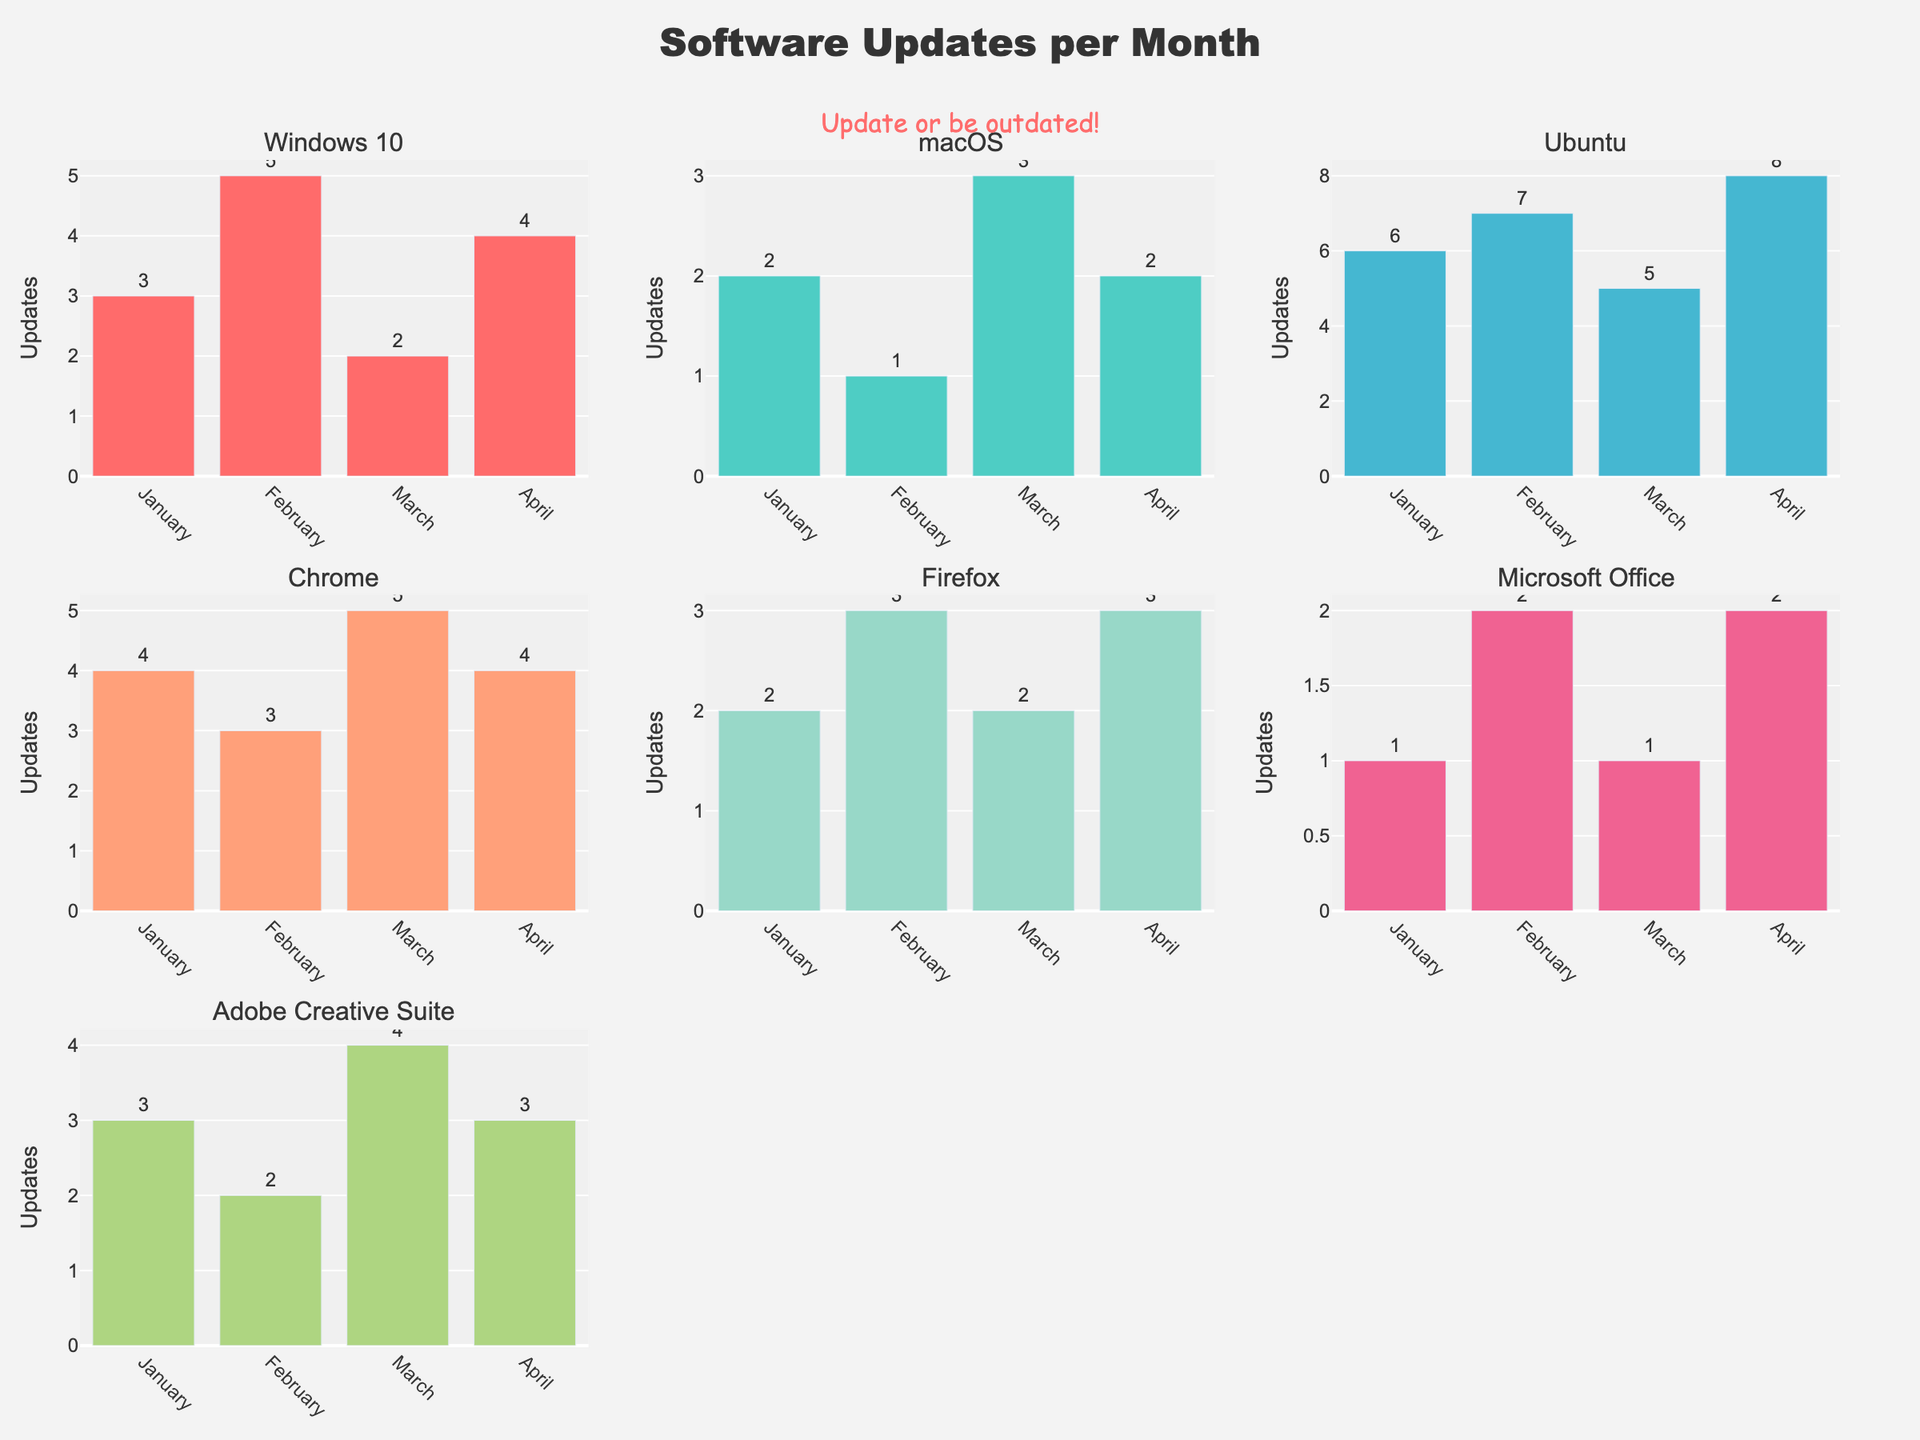Which operating system had the highest number of updates in February? Looking at the February updates across all subplots, Ubuntu recorded the highest with 7 updates.
Answer: Ubuntu How many updates did macOS receive in total over the four months? Summing the updates for macOS across January (2), February (1), March (3), and April (2): 2 + 1 + 3 + 2 = 8 updates.
Answer: 8 Which month had the lowest number of updates for Microsoft Office? According to the subplot for Microsoft Office, January and March had the lowest number of updates with 1 each.
Answer: January and March Compare the updates of Firefox and Chrome in April. Which had more updates? In April, both Firefox and Chrome received 3 and 4 updates respectively, so Chrome had one more update.
Answer: Chrome What is the average number of updates for Ubuntu across the four months? Adding Ubuntu's updates: 6 (Jan) + 7 (Feb) + 5 (Mar) + 8 (Apr) gives 26. Dividing by 4 months: 26 / 4 = 6.5 updates on average.
Answer: 6.5 Which system or application had the most consistent number of updates over the months? Checking the consistency: Chrome and Firefox each had relatively consistent updates (Chrome: 4, 3, 5, 4; Firefox: 2, 3, 2, 3). The minor variations suggest Firefox had the fewest fluctuations.
Answer: Firefox How do the software update trends differ between Windows 10 and Adobe Creative Suite? Windows 10 fluctuated between 2 to 5 updates while Adobe Creative Suite ranged 2 to 4 updates, but both had highs and lows without a clear upward or downward trend.
Answer: Fluctuating without clear trends What is the total number of updates across all systems in March? Summing March updates: Windows 10 (2) + macOS (3) + Ubuntu (5) + Chrome (5) + Firefox (2) + Microsoft Office (1) + Adobe Creative Suite (4) gives 22 updates.
Answer: 22 Which two systems or applications had exactly the same number of updates in January? Both Chrome and Adobe Creative Suite had 4 updates each in January.
Answer: Chrome and Adobe Creative Suite What's the highest number of updates recorded by any system or application in a single month? By evaluating each subplot, Ubuntu had the highest in a single month with 8 updates in April.
Answer: 8 